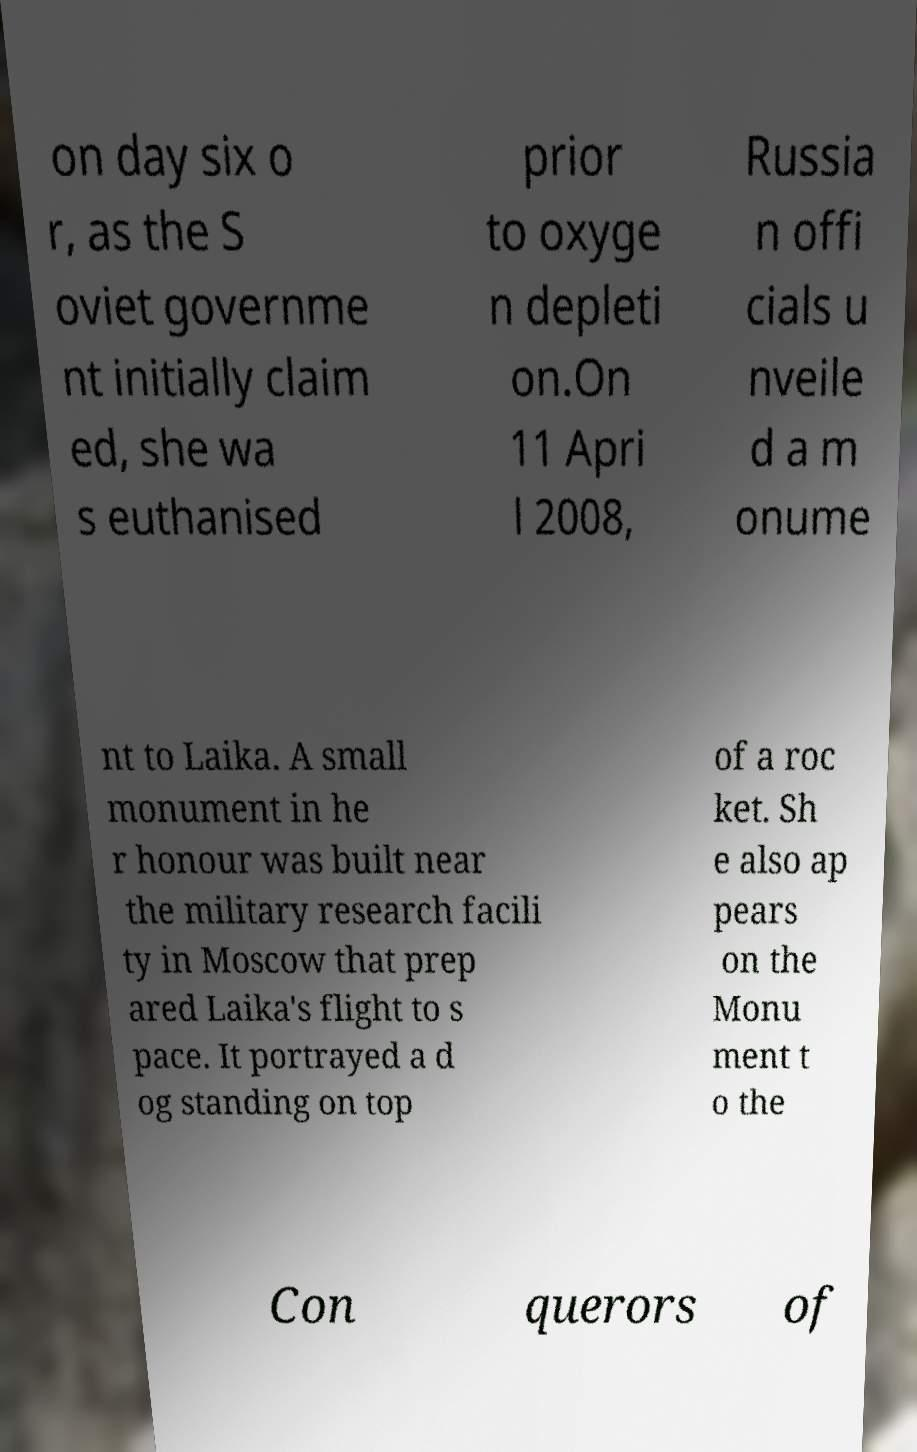Could you extract and type out the text from this image? on day six o r, as the S oviet governme nt initially claim ed, she wa s euthanised prior to oxyge n depleti on.On 11 Apri l 2008, Russia n offi cials u nveile d a m onume nt to Laika. A small monument in he r honour was built near the military research facili ty in Moscow that prep ared Laika's flight to s pace. It portrayed a d og standing on top of a roc ket. Sh e also ap pears on the Monu ment t o the Con querors of 